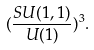Convert formula to latex. <formula><loc_0><loc_0><loc_500><loc_500>( \frac { S U ( 1 , 1 ) } { U ( 1 ) } ) ^ { 3 } .</formula> 